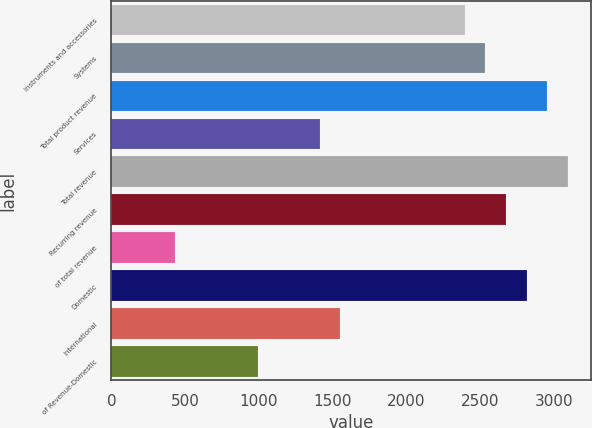Convert chart to OTSL. <chart><loc_0><loc_0><loc_500><loc_500><bar_chart><fcel>Instruments and accessories<fcel>Systems<fcel>Total product revenue<fcel>Services<fcel>Total revenue<fcel>Recurring revenue<fcel>of total revenue<fcel>Domestic<fcel>International<fcel>of Revenue-Domestic<nl><fcel>2395.8<fcel>2536.2<fcel>2957.4<fcel>1413<fcel>3097.8<fcel>2676.6<fcel>430.2<fcel>2817<fcel>1553.4<fcel>991.8<nl></chart> 